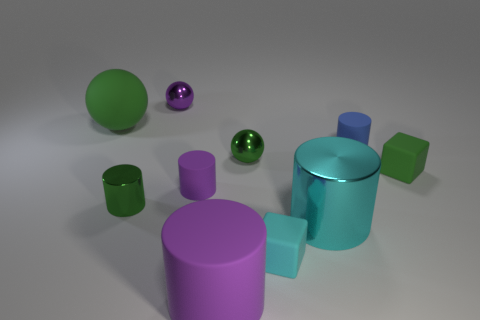Subtract all cyan cylinders. How many cylinders are left? 4 Subtract all green metallic cylinders. How many cylinders are left? 4 Subtract all brown cylinders. Subtract all blue balls. How many cylinders are left? 5 Subtract all balls. How many objects are left? 7 Subtract all large yellow matte cylinders. Subtract all big green matte objects. How many objects are left? 9 Add 6 green rubber objects. How many green rubber objects are left? 8 Add 9 tiny cyan objects. How many tiny cyan objects exist? 10 Subtract 1 cyan blocks. How many objects are left? 9 